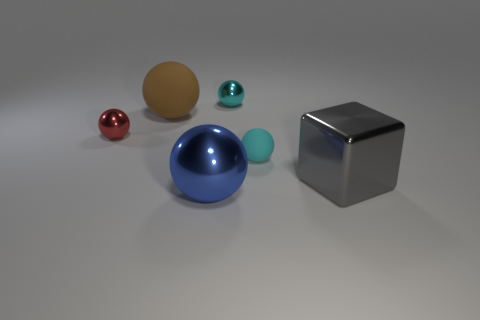Is there anything else that is the same shape as the big gray thing?
Your answer should be compact. No. Are there any brown matte balls?
Provide a short and direct response. Yes. Are there any large matte spheres in front of the metal sphere in front of the matte thing that is right of the big blue metal ball?
Your answer should be compact. No. What number of small things are either cyan cubes or shiny cubes?
Give a very brief answer. 0. There is a metallic cube that is the same size as the brown rubber sphere; what color is it?
Give a very brief answer. Gray. What number of small matte balls are in front of the cyan metallic sphere?
Make the answer very short. 1. Is there a big blue thing that has the same material as the big gray object?
Keep it short and to the point. Yes. What color is the rubber ball to the right of the blue metallic object?
Provide a succinct answer. Cyan. Are there the same number of spheres that are on the right side of the tiny cyan rubber ball and large shiny objects that are to the left of the small cyan metal thing?
Ensure brevity in your answer.  No. What material is the small cyan ball that is in front of the metal ball that is on the left side of the large blue metal thing?
Make the answer very short. Rubber. 